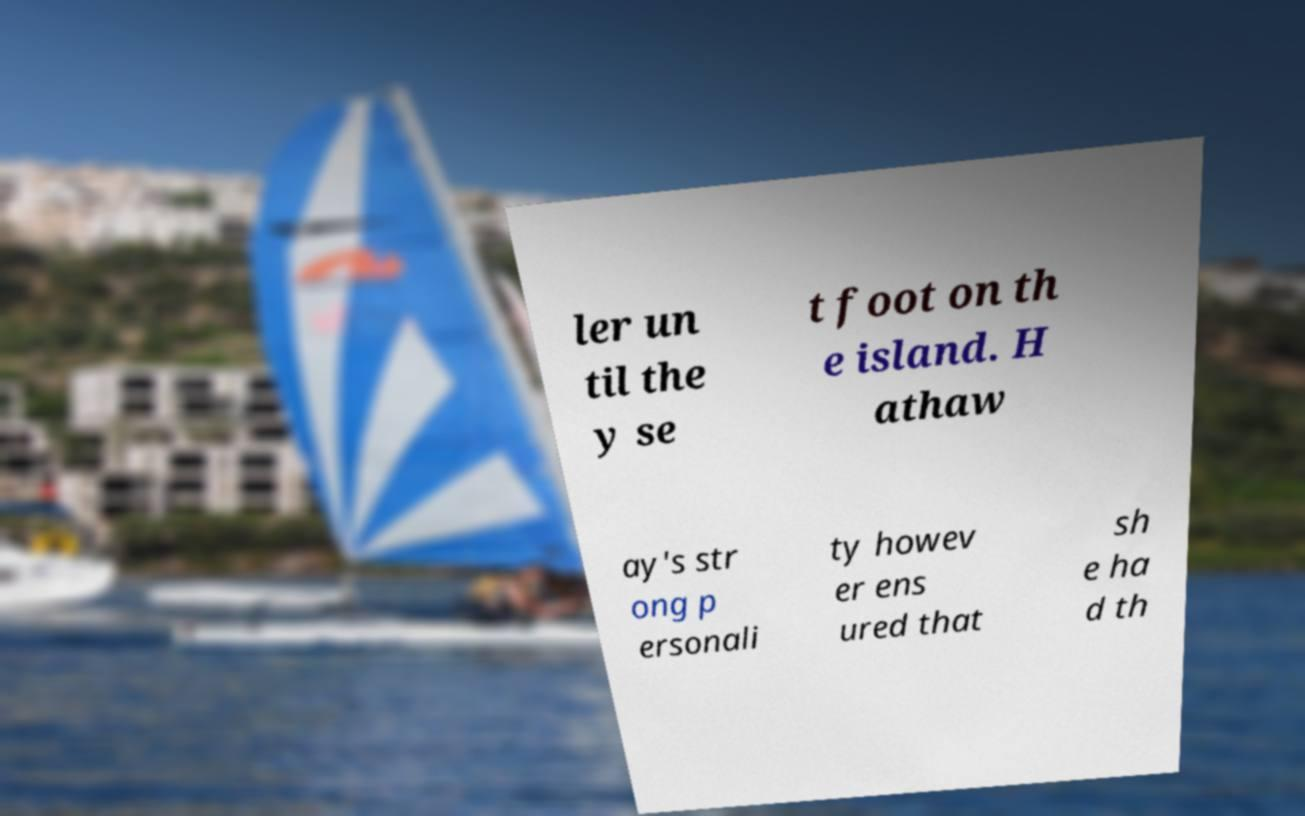Please identify and transcribe the text found in this image. ler un til the y se t foot on th e island. H athaw ay's str ong p ersonali ty howev er ens ured that sh e ha d th 